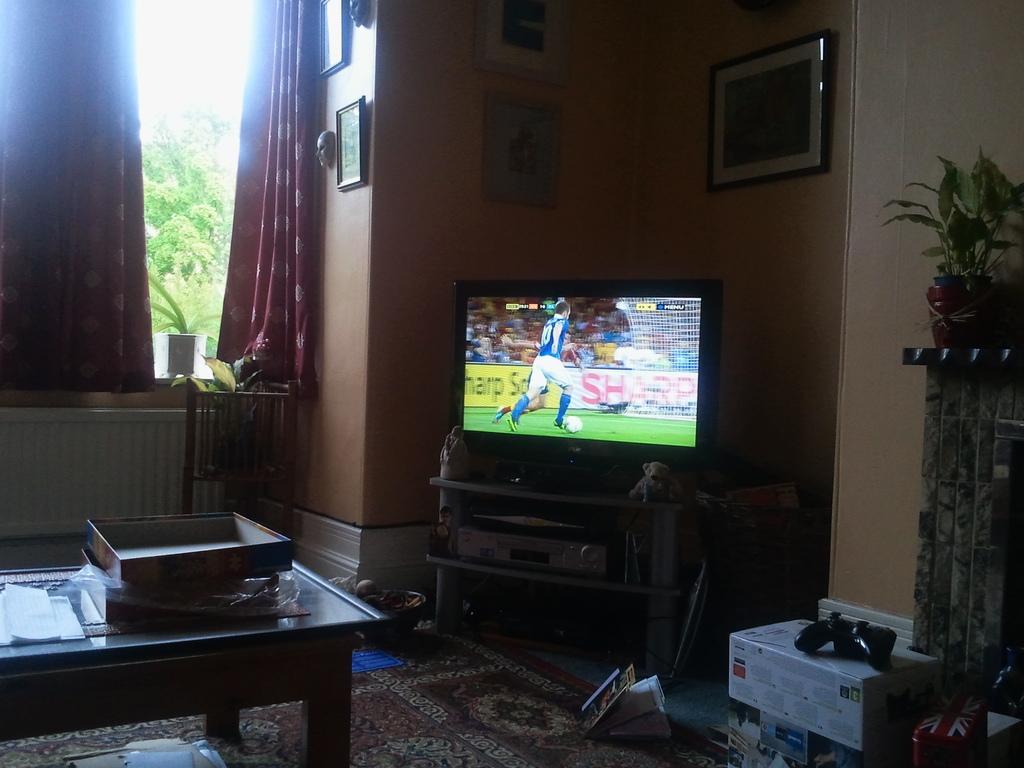Describe this image in one or two sentences. This image is taken inside the house in the center there is a TV on the stand and on the left side there is a table on the table there are boxes. On the right side there is a white colour box and on the box there is a black colour object. In the center there are red colour curtains and on the wall there are frames, outside the window there are trees. On the floor in the center there is a mat. 